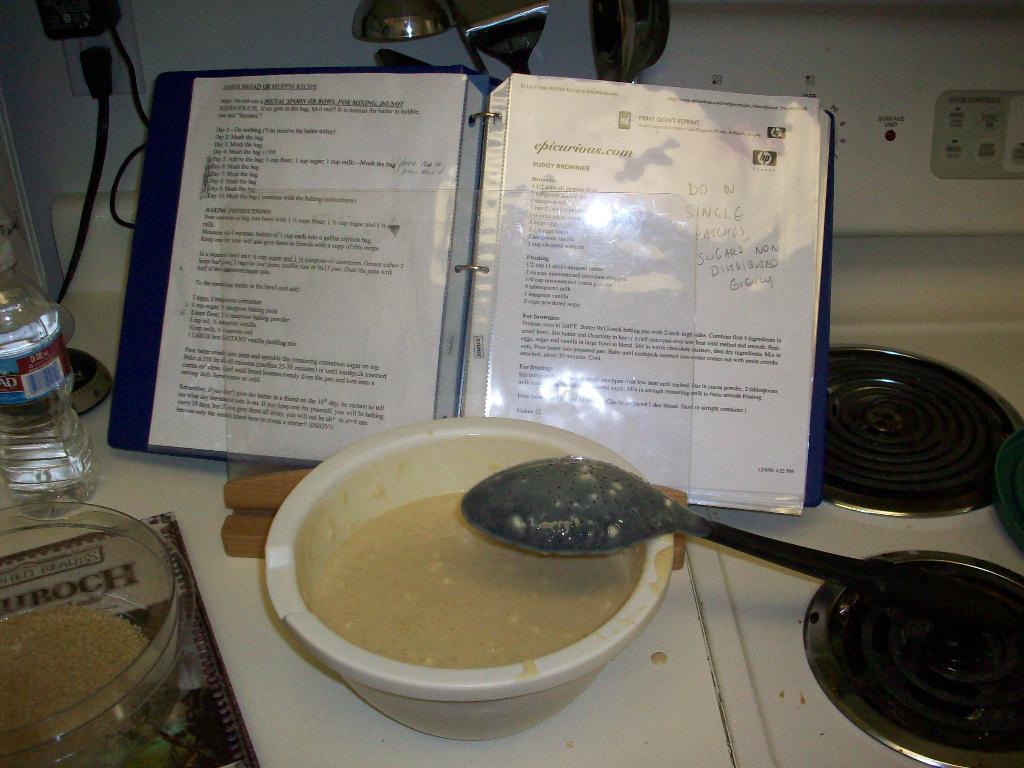In one or two sentences, can you explain what this image depicts? In this image in the center there is a book with some text written on it. In front of the book in the front there is a bowl and there is a spoon. On the left side of the bowel there is a bottle and there is a container. In the background there are wires and there are spoons. 